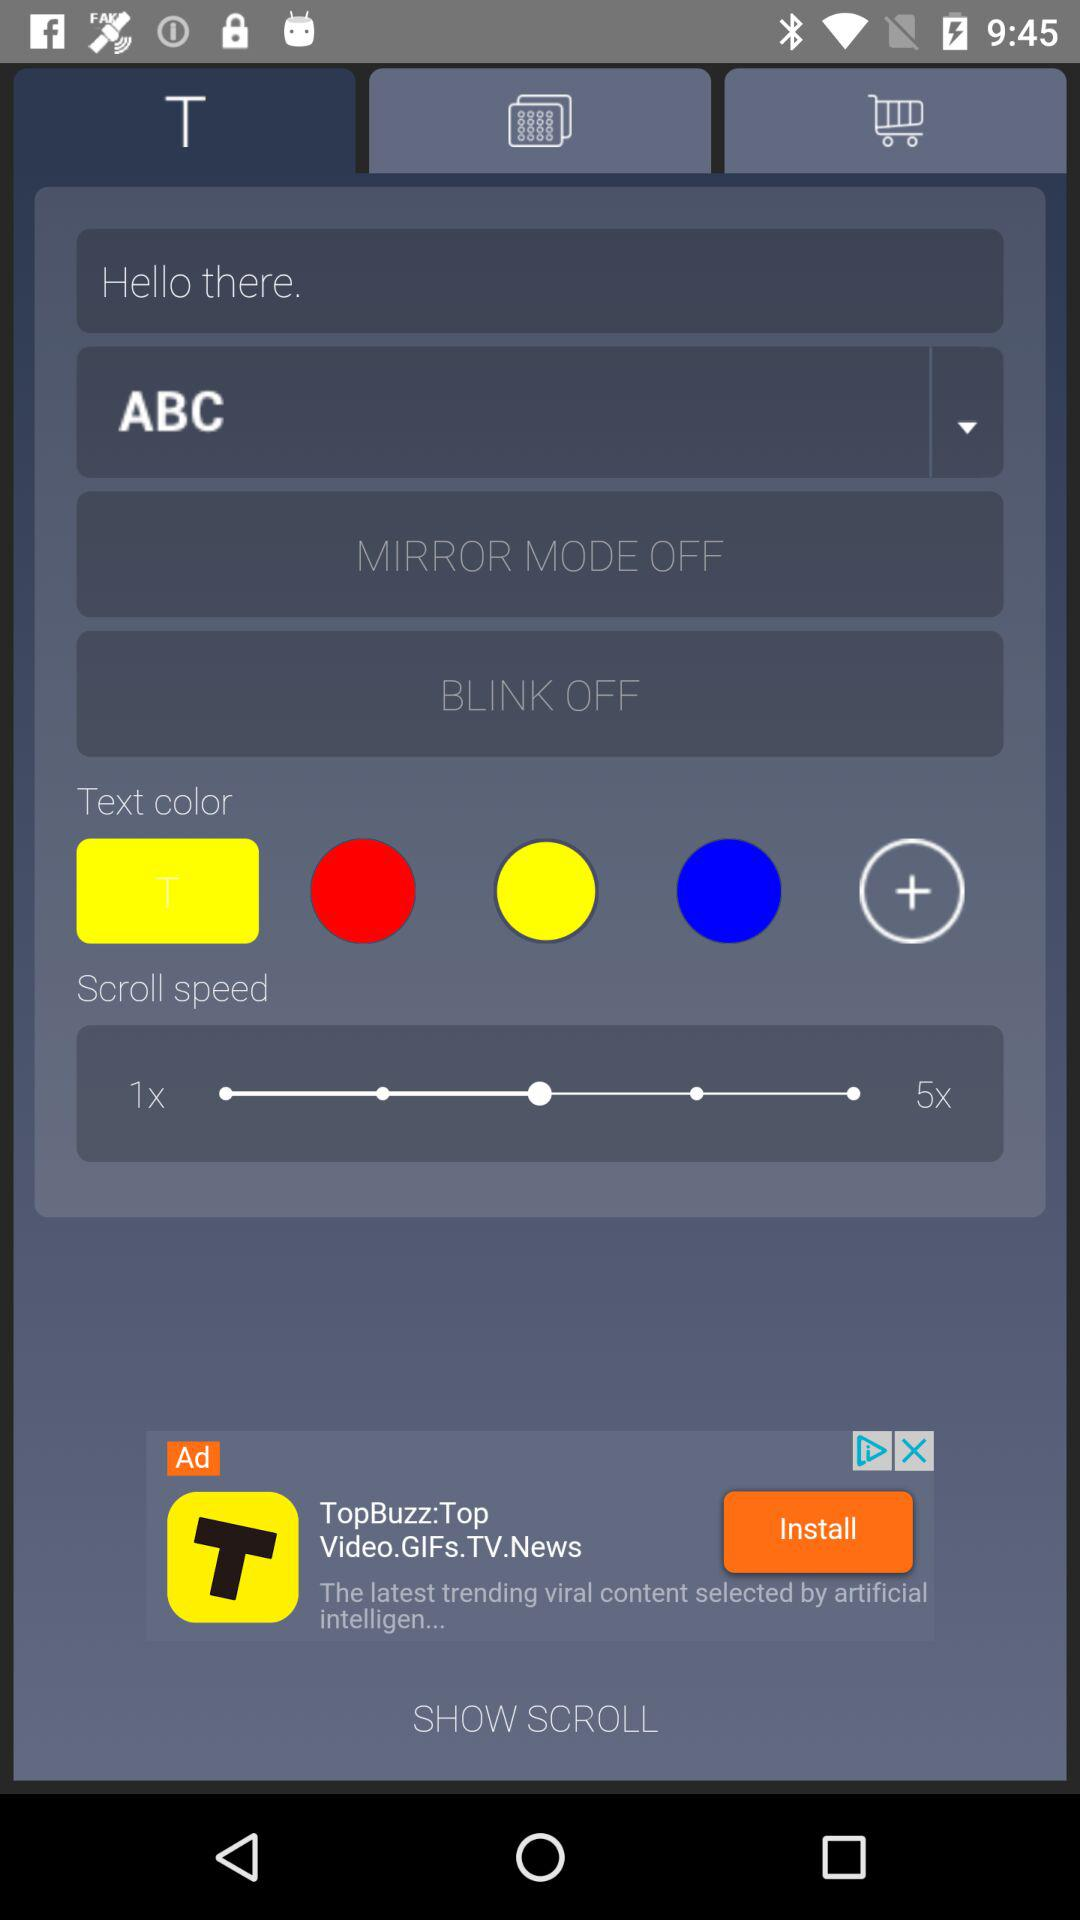What is the status of "BLINK"? The status of "BLINK" is "off". 